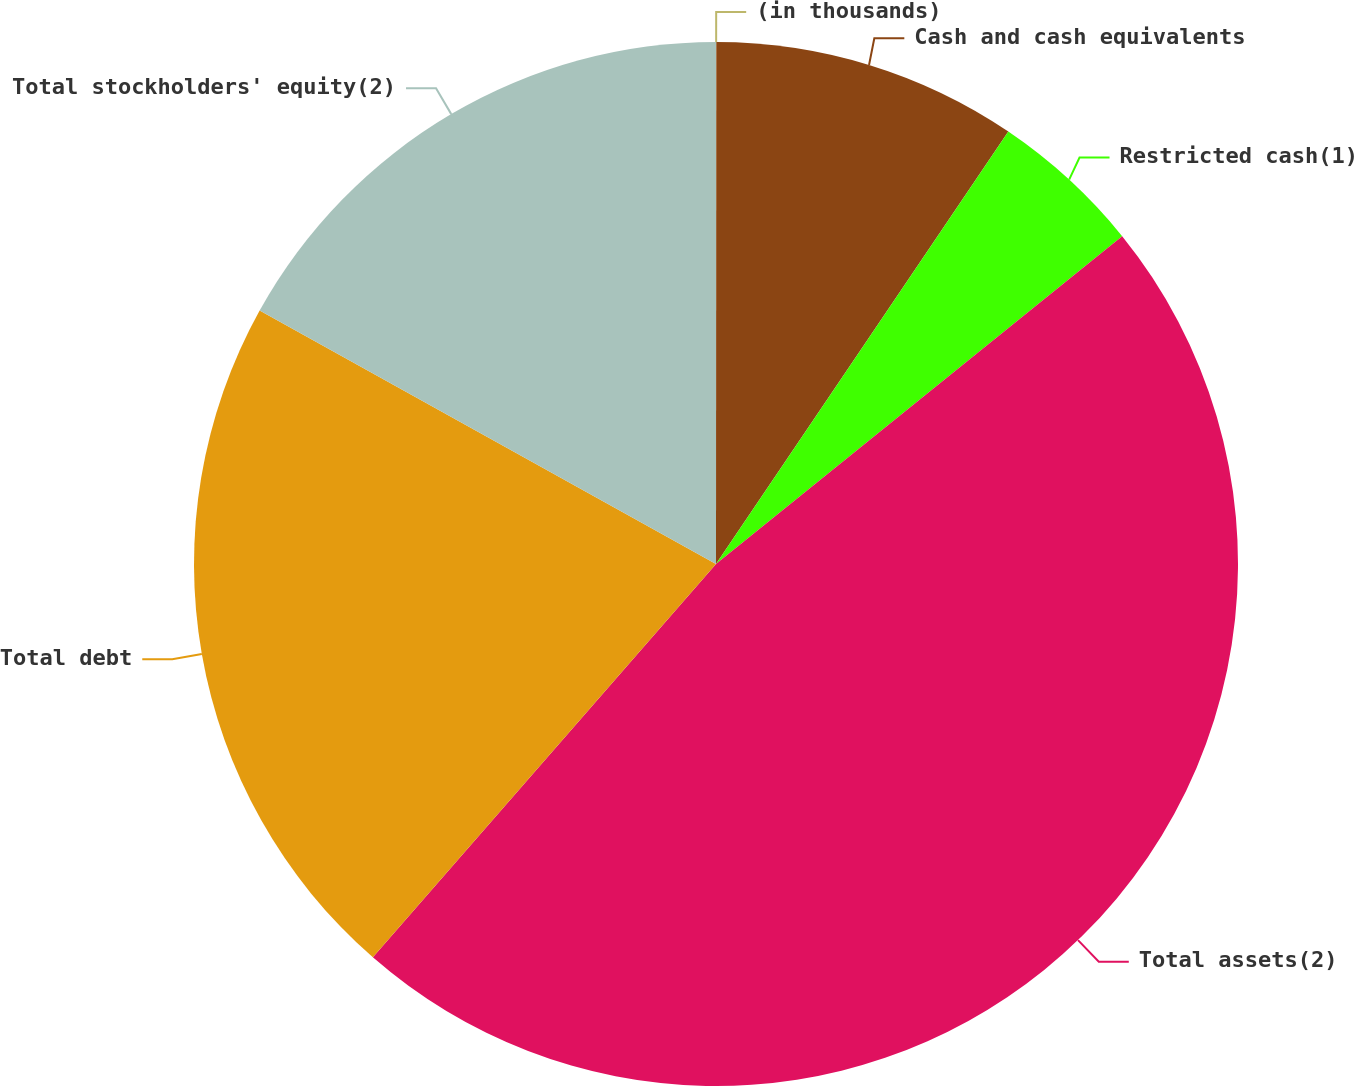Convert chart to OTSL. <chart><loc_0><loc_0><loc_500><loc_500><pie_chart><fcel>(in thousands)<fcel>Cash and cash equivalents<fcel>Restricted cash(1)<fcel>Total assets(2)<fcel>Total debt<fcel>Total stockholders' equity(2)<nl><fcel>0.01%<fcel>9.45%<fcel>4.73%<fcel>47.22%<fcel>21.65%<fcel>16.93%<nl></chart> 